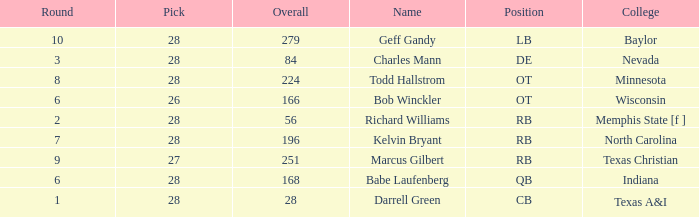What is the lowest round of the position de player with an overall less than 84? None. 